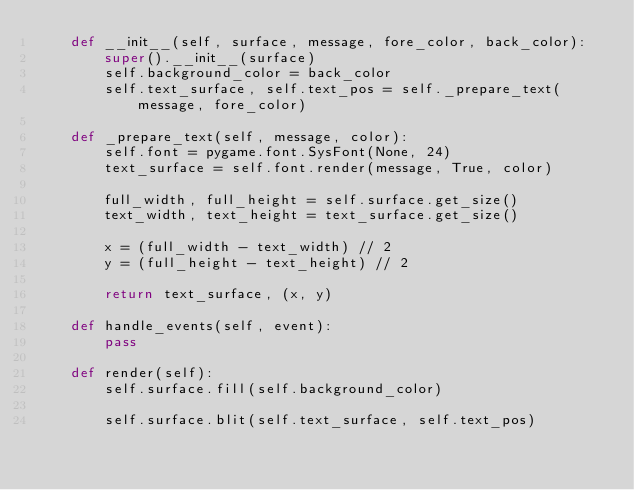<code> <loc_0><loc_0><loc_500><loc_500><_Python_>    def __init__(self, surface, message, fore_color, back_color):
        super().__init__(surface)
        self.background_color = back_color
        self.text_surface, self.text_pos = self._prepare_text(message, fore_color)

    def _prepare_text(self, message, color):
        self.font = pygame.font.SysFont(None, 24)
        text_surface = self.font.render(message, True, color)

        full_width, full_height = self.surface.get_size()
        text_width, text_height = text_surface.get_size()

        x = (full_width - text_width) // 2
        y = (full_height - text_height) // 2

        return text_surface, (x, y)

    def handle_events(self, event):
        pass

    def render(self):
        self.surface.fill(self.background_color)

        self.surface.blit(self.text_surface, self.text_pos)
</code> 